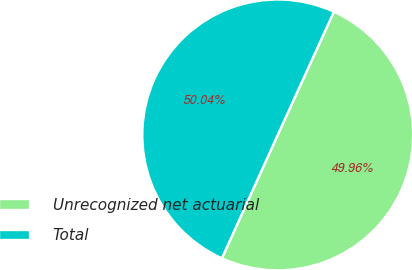<chart> <loc_0><loc_0><loc_500><loc_500><pie_chart><fcel>Unrecognized net actuarial<fcel>Total<nl><fcel>49.96%<fcel>50.04%<nl></chart> 